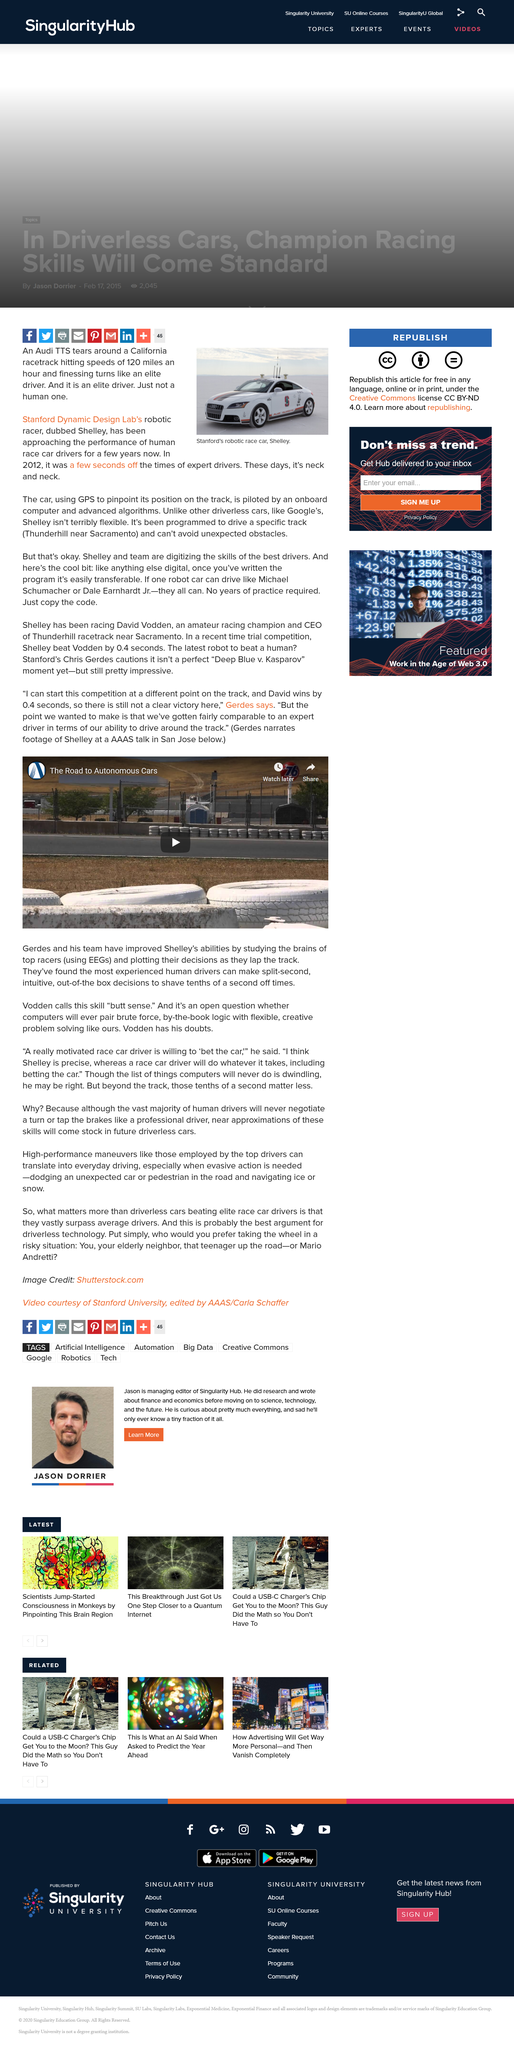Outline some significant characteristics in this image. Shelley is a robotic racer created by the Stanford Dynamic Design Lab. The Audi TTS can reach a speed of 120 miles per hour. In 2012, the self-driving car's performance was slightly below that of expert drivers. 